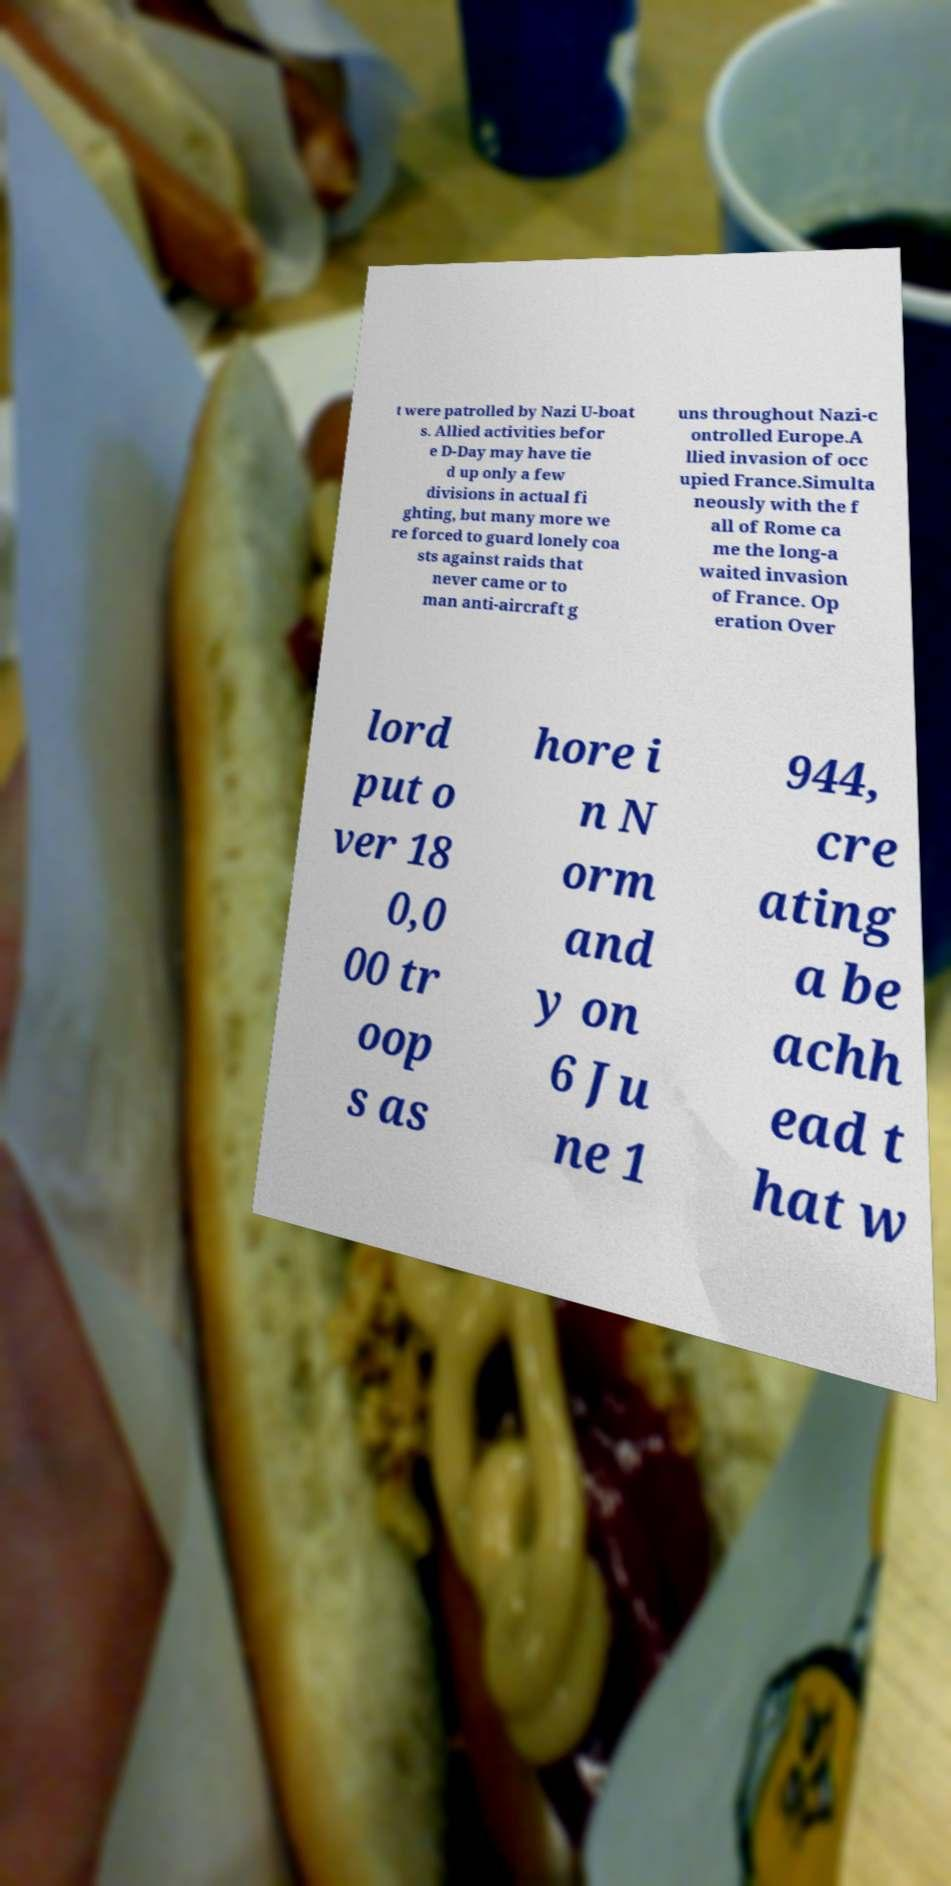What messages or text are displayed in this image? I need them in a readable, typed format. t were patrolled by Nazi U-boat s. Allied activities befor e D-Day may have tie d up only a few divisions in actual fi ghting, but many more we re forced to guard lonely coa sts against raids that never came or to man anti-aircraft g uns throughout Nazi-c ontrolled Europe.A llied invasion of occ upied France.Simulta neously with the f all of Rome ca me the long-a waited invasion of France. Op eration Over lord put o ver 18 0,0 00 tr oop s as hore i n N orm and y on 6 Ju ne 1 944, cre ating a be achh ead t hat w 